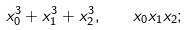Convert formula to latex. <formula><loc_0><loc_0><loc_500><loc_500>x _ { 0 } ^ { 3 } + x _ { 1 } ^ { 3 } + x _ { 2 } ^ { 3 } , \quad x _ { 0 } x _ { 1 } x _ { 2 } ;</formula> 